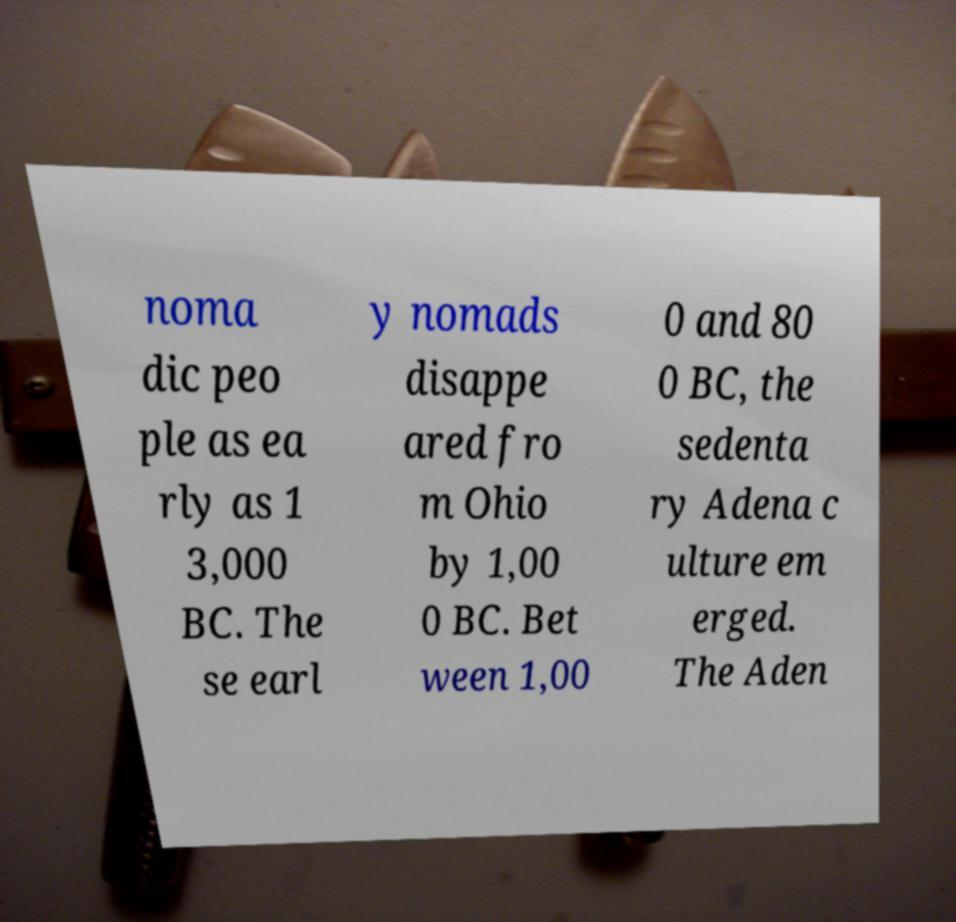For documentation purposes, I need the text within this image transcribed. Could you provide that? noma dic peo ple as ea rly as 1 3,000 BC. The se earl y nomads disappe ared fro m Ohio by 1,00 0 BC. Bet ween 1,00 0 and 80 0 BC, the sedenta ry Adena c ulture em erged. The Aden 